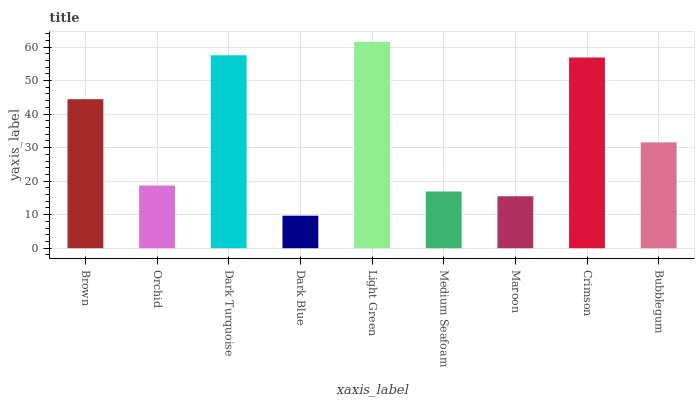Is Dark Blue the minimum?
Answer yes or no. Yes. Is Light Green the maximum?
Answer yes or no. Yes. Is Orchid the minimum?
Answer yes or no. No. Is Orchid the maximum?
Answer yes or no. No. Is Brown greater than Orchid?
Answer yes or no. Yes. Is Orchid less than Brown?
Answer yes or no. Yes. Is Orchid greater than Brown?
Answer yes or no. No. Is Brown less than Orchid?
Answer yes or no. No. Is Bubblegum the high median?
Answer yes or no. Yes. Is Bubblegum the low median?
Answer yes or no. Yes. Is Dark Blue the high median?
Answer yes or no. No. Is Light Green the low median?
Answer yes or no. No. 